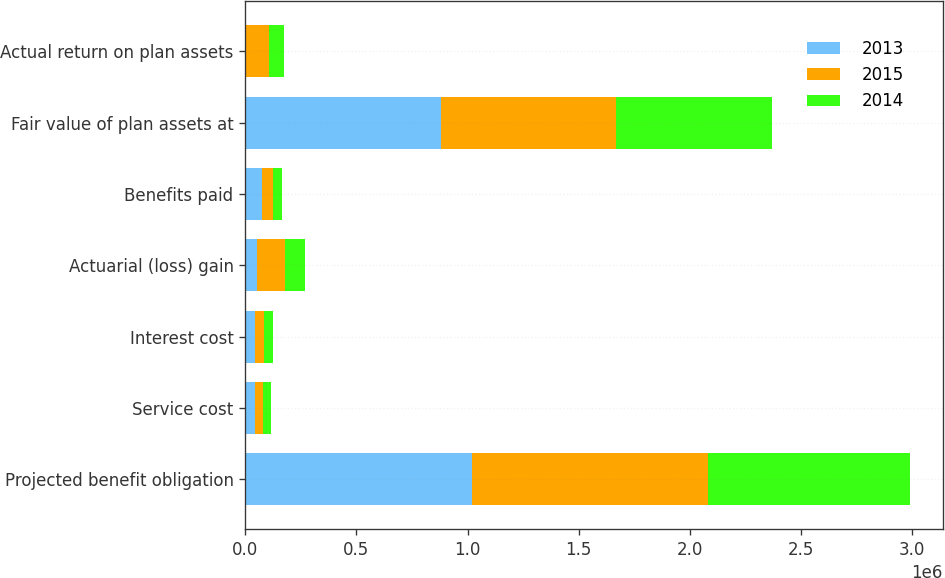Convert chart. <chart><loc_0><loc_0><loc_500><loc_500><stacked_bar_chart><ecel><fcel>Projected benefit obligation<fcel>Service cost<fcel>Interest cost<fcel>Actuarial (loss) gain<fcel>Benefits paid<fcel>Fair value of plan assets at<fcel>Actual return on plan assets<nl><fcel>2013<fcel>1.01859e+06<fcel>41989<fcel>41766<fcel>52201<fcel>77002<fcel>879211<fcel>5458<nl><fcel>2015<fcel>1.06404e+06<fcel>36609<fcel>43613<fcel>127940<fcel>50063<fcel>786750<fcel>102628<nl><fcel>2014<fcel>905943<fcel>38580<fcel>38243<fcel>89029<fcel>38023<fcel>704976<fcel>64641<nl></chart> 